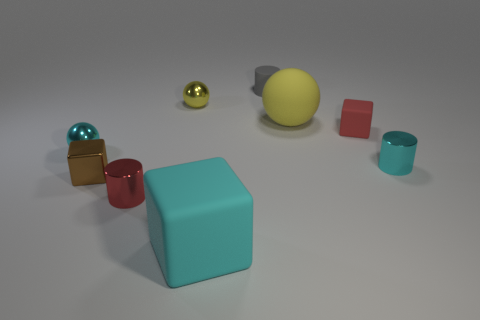Add 1 tiny yellow spheres. How many objects exist? 10 Subtract all tiny rubber cylinders. How many cylinders are left? 2 Subtract all blocks. How many objects are left? 6 Subtract all yellow cylinders. How many purple spheres are left? 0 Subtract all small rubber cylinders. Subtract all cyan metal cylinders. How many objects are left? 7 Add 9 tiny red cylinders. How many tiny red cylinders are left? 10 Add 2 cyan spheres. How many cyan spheres exist? 3 Subtract all red blocks. How many blocks are left? 2 Subtract 0 green cubes. How many objects are left? 9 Subtract 1 cylinders. How many cylinders are left? 2 